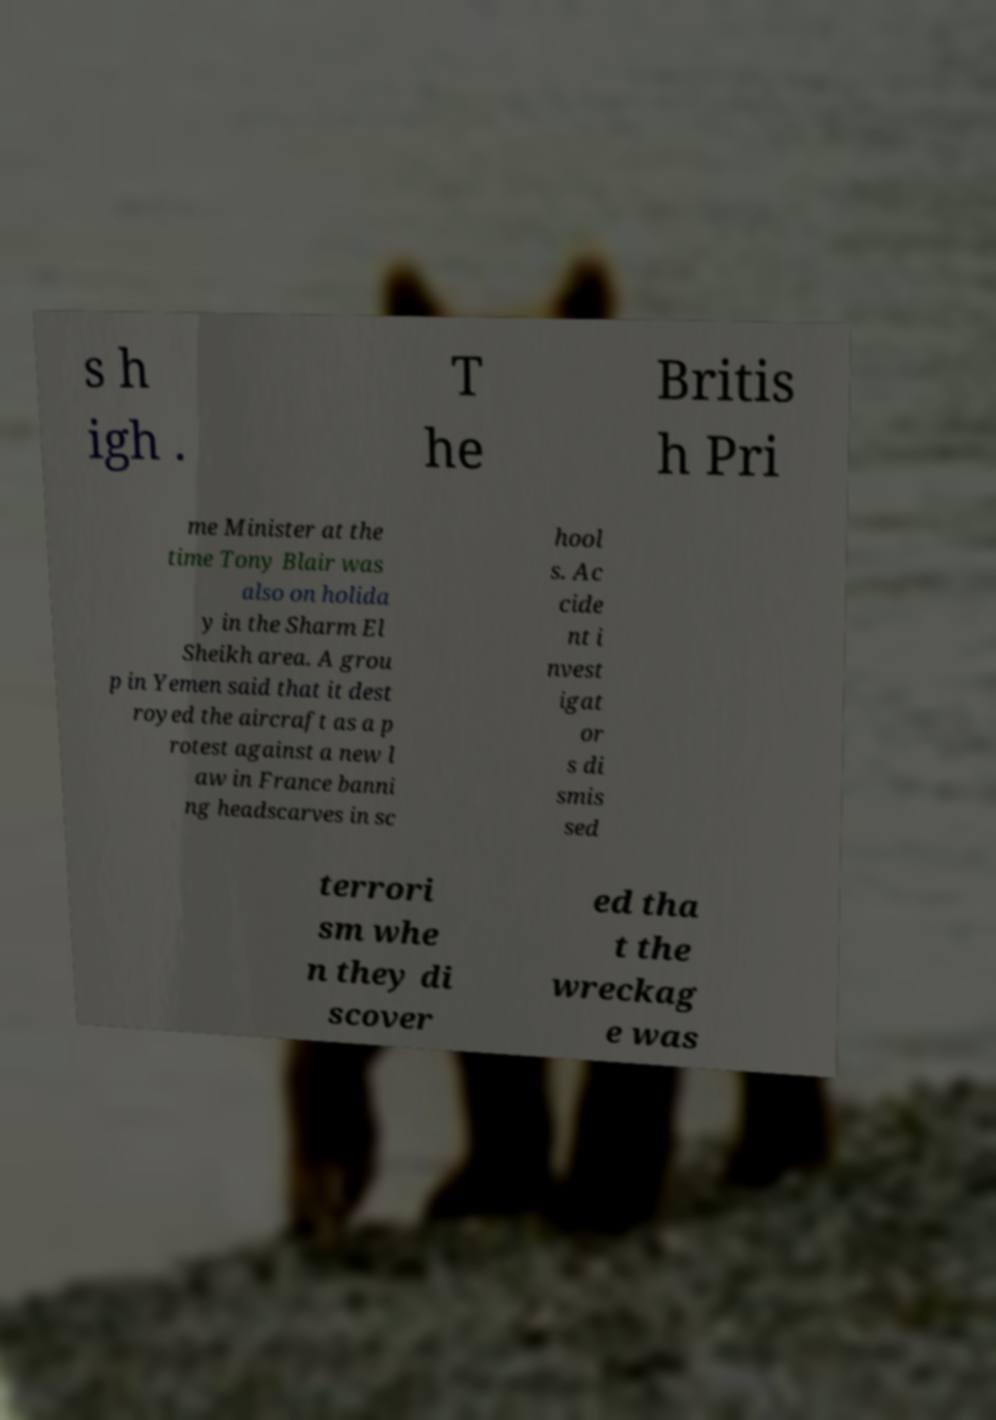Please identify and transcribe the text found in this image. s h igh . T he Britis h Pri me Minister at the time Tony Blair was also on holida y in the Sharm El Sheikh area. A grou p in Yemen said that it dest royed the aircraft as a p rotest against a new l aw in France banni ng headscarves in sc hool s. Ac cide nt i nvest igat or s di smis sed terrori sm whe n they di scover ed tha t the wreckag e was 